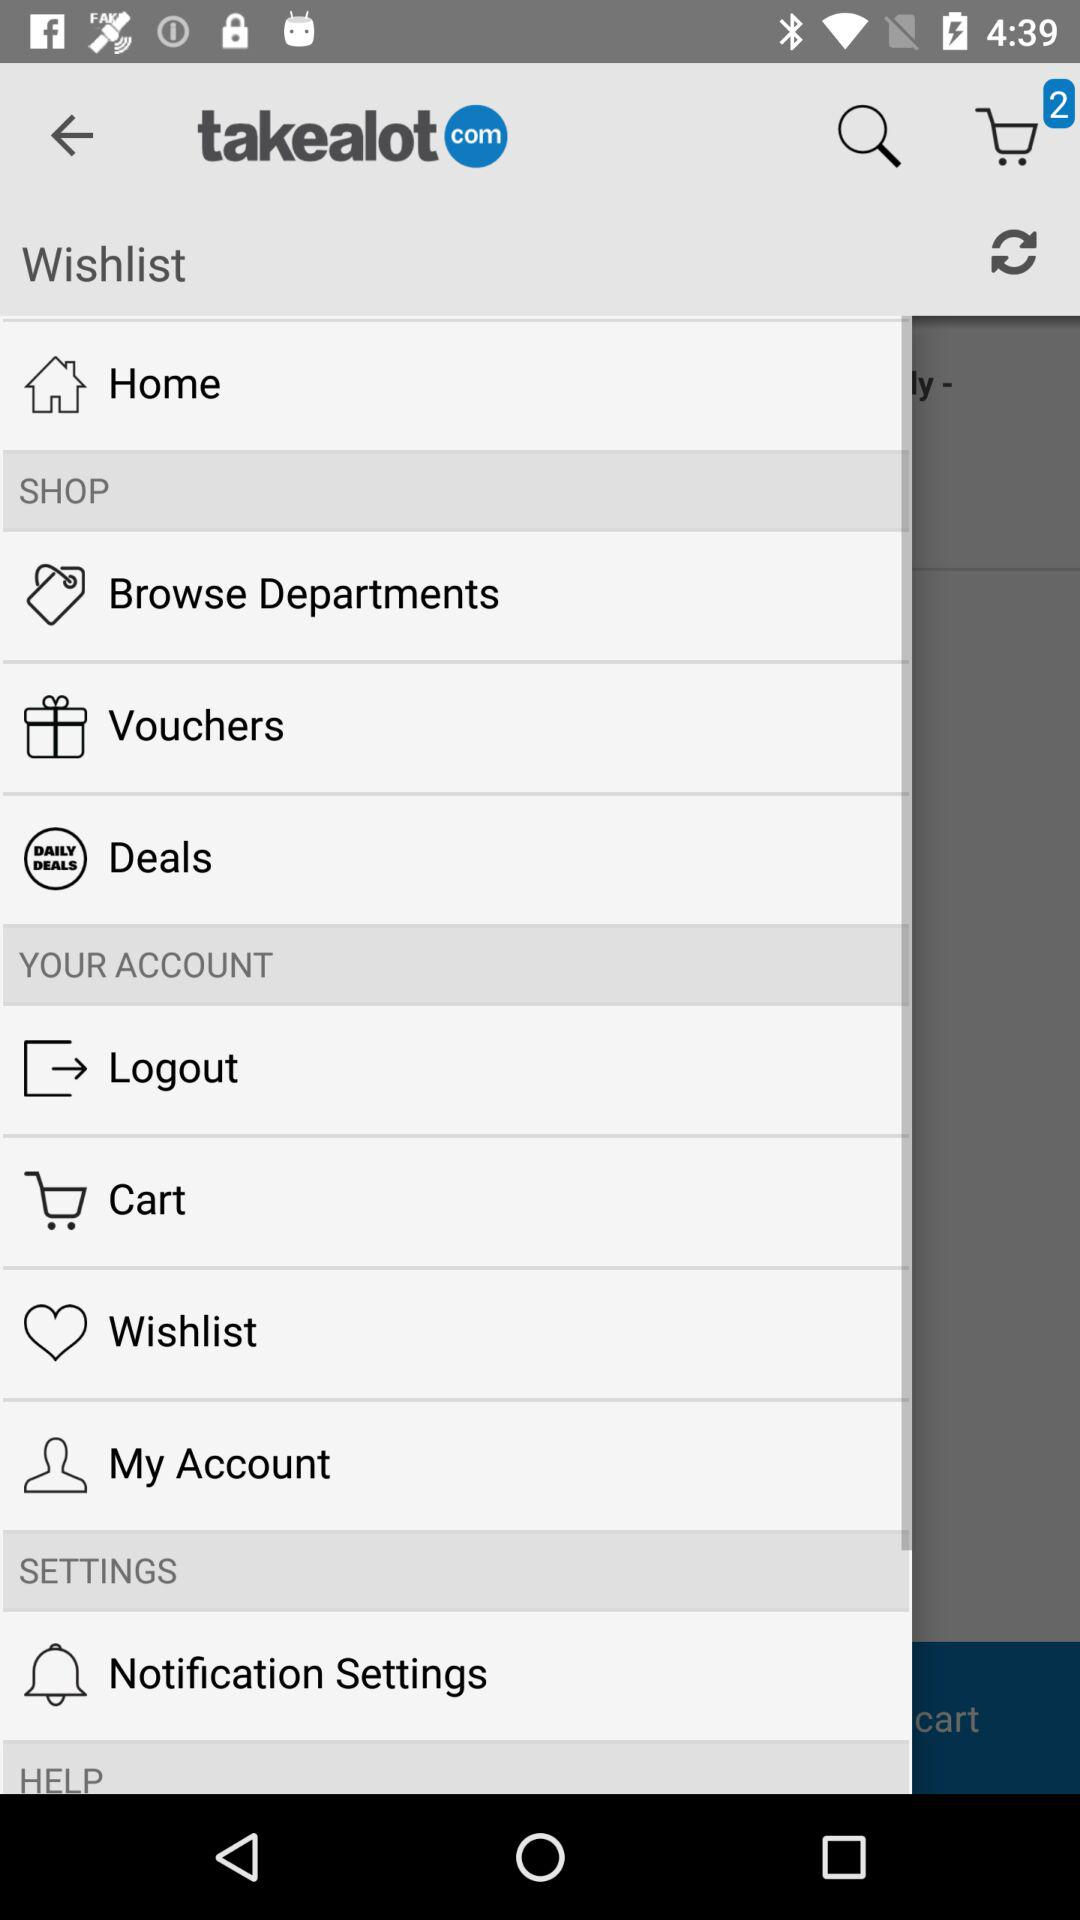What is the name of the application? The name of the application is "takealot". 